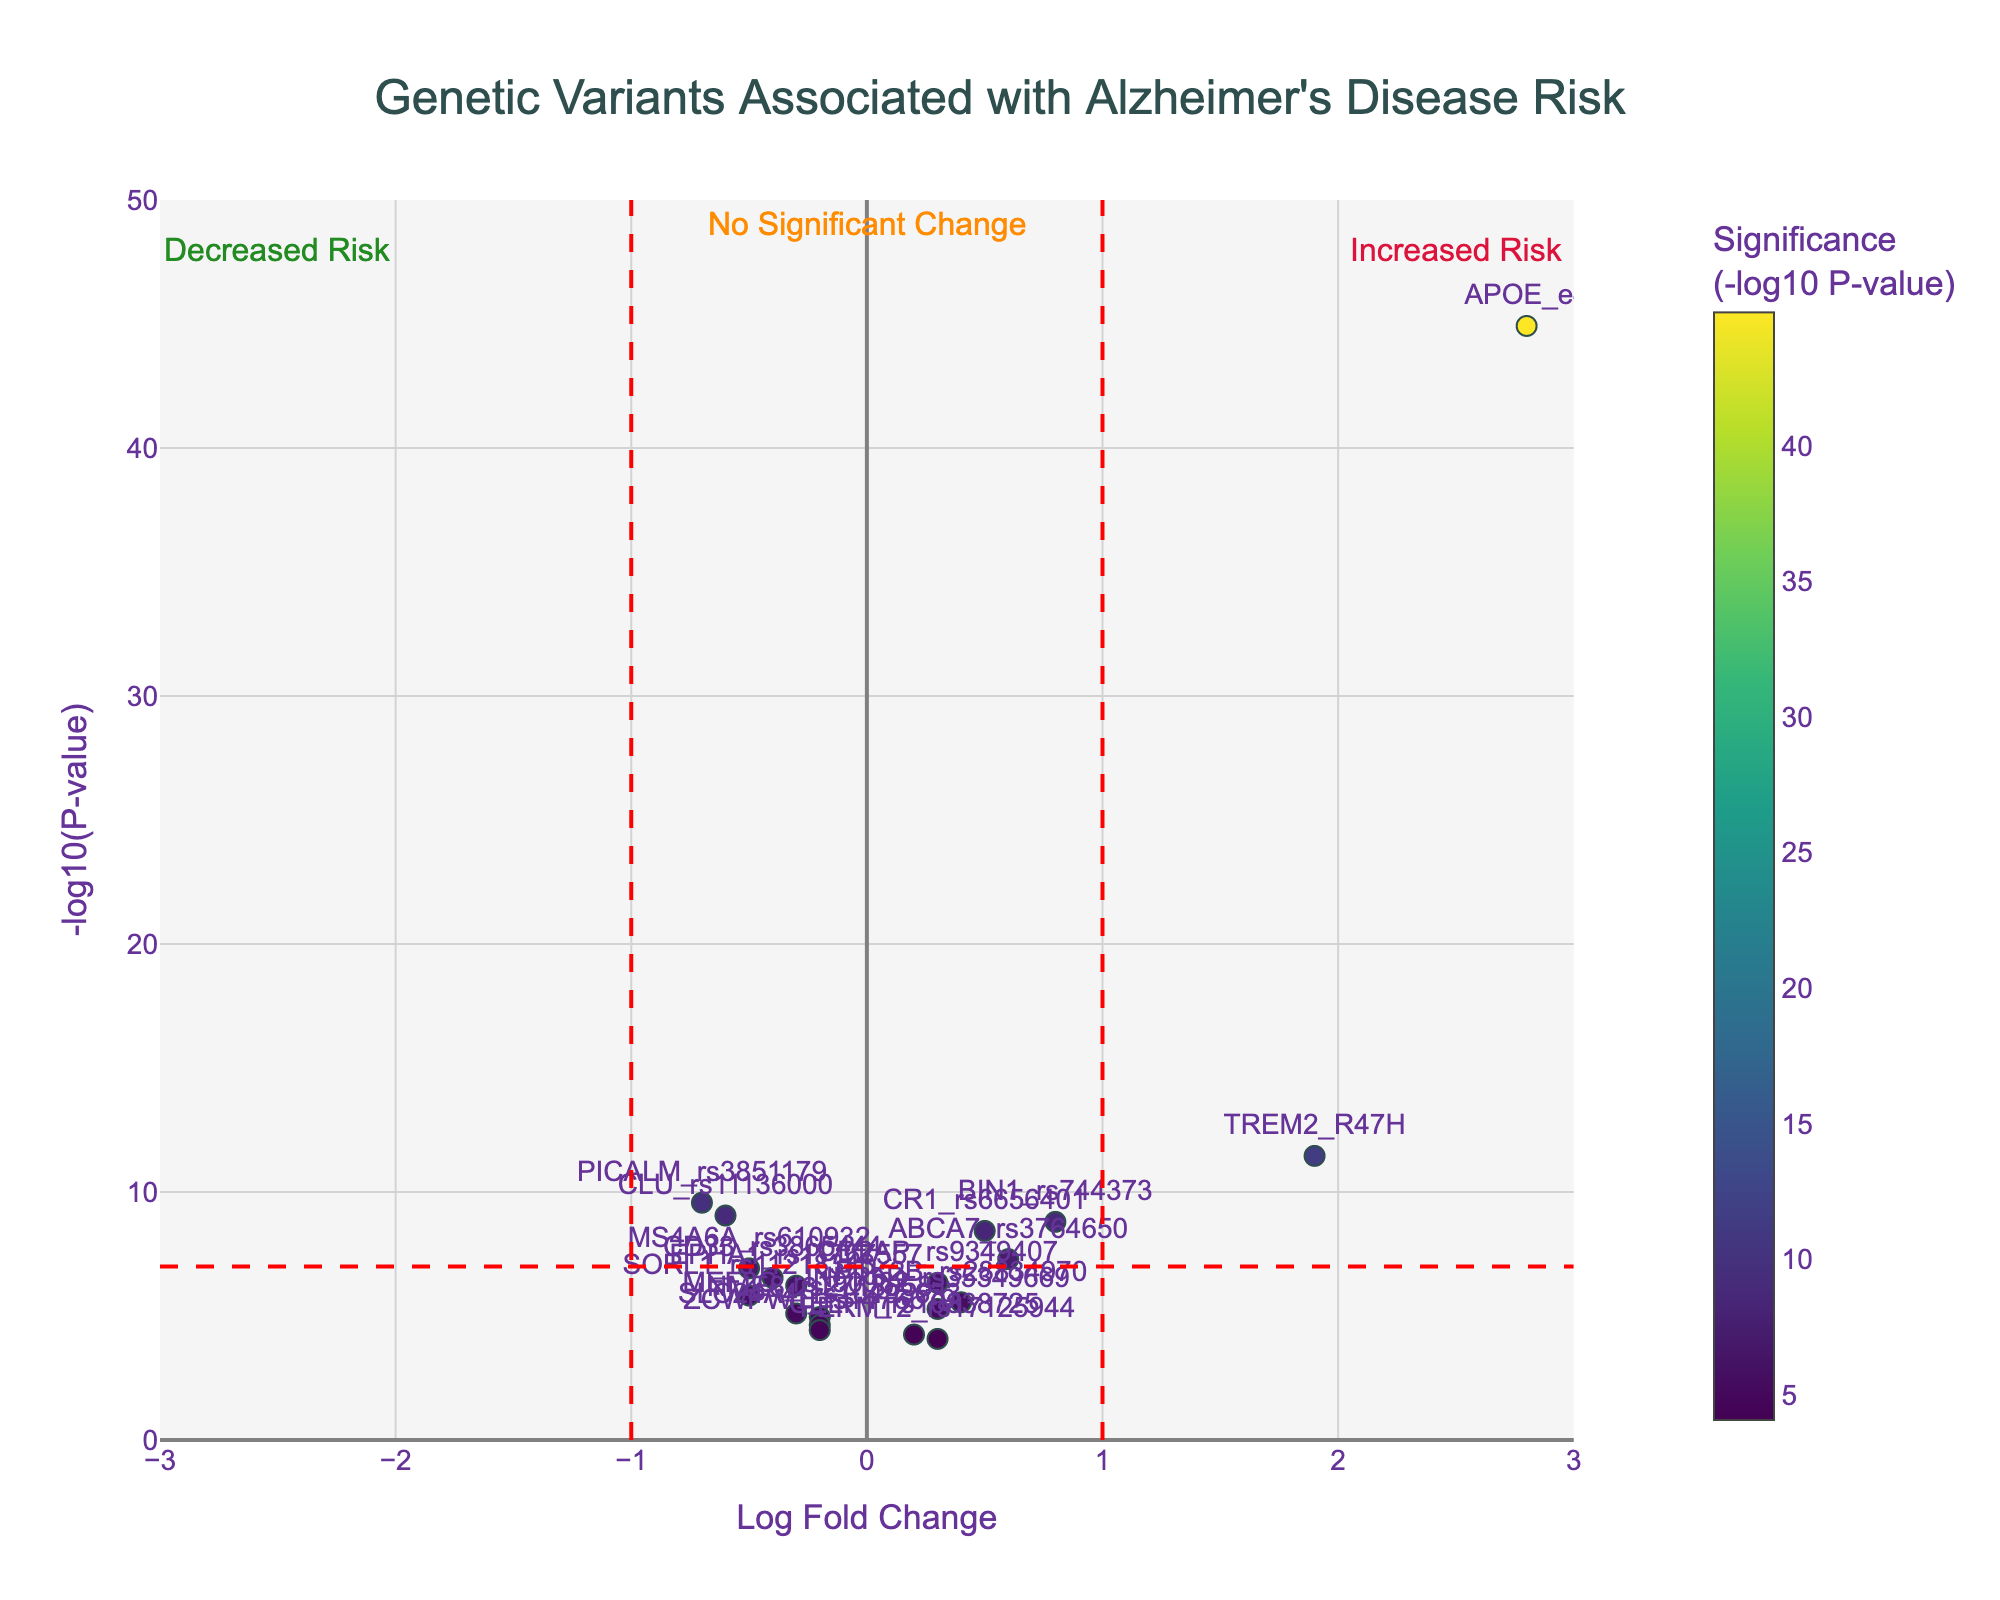What is the title of this plot? The title is displayed at the top center of the plot. Reading the title gives clear information about the context of the figure.
Answer: Genetic Variants Associated with Alzheimer's Disease Risk What do the colors of the data points represent? The color of the data points is linked to the significance (-log10 P-value) of each SNP and this is explained by the color bar on the right-hand side of the plot.
Answer: Significance (-log10 P-value) How many genetic variants (SNPs) are plotted in this figure? Each data point represents an SNP, and by counting all unique SNP labels in the figure, we find the number of plotted SNPs.
Answer: 19 Which SNP has the highest significance for Alzheimer’s disease risk? The SNP with the highest -log10(P-value) represents the most significant genetic variant. By looking at the y-axis and finding the topmost point, we identify the SNP.
Answer: APOE_e4 Which SNPs are considered to indicate an increased risk of Alzheimer’s disease? SNPs with a positive Log Fold Change value indicate increased risk. By looking at the positive side of the x-axis, we can identify these SNPs.
Answer: APOE_e4, TREM2_R47H, BIN1_rs744373, CR1_rs6656401, ABCA7_rs3764650, CD2AP_rs9349407, PTK2B_rs28834970, INPP5D_rs35349669, FERMT2_rs17125944 What does a Log Fold Change of negative value indicate in terms of Alzheimer's disease risk? A negative Log Fold Change value indicates a decreased risk of Alzheimer's disease, as per the annotations in the plot.
Answer: Decreased risk Which SNP has the smallest Log Fold Change but is still considered significant? By identifying SNPs with significant P-values (-log10(P-value) > 7), we locate the smallest Log Fold Change which is closest to zero.
Answer: CD2AP_rs9349407 How many SNPs exhibit a significant association (with -log10(P-value) > 7) and a decreased risk (negative Log Fold Change)? By looking at the threshold line for -log10(P-value) and counts of points on the left side of the x-axis, we determine the number of such SNPs.
Answer: 4 (PICALM_rs3851179, CLU_rs11136000, MS4A6A_rs610932, SORL1_rs11218343) Which has greater significance, TREM2_R47H or PICALM_rs3851179? Compare the y-values of TREM2_R47H and PICALM_rs3851179 to determine which one is higher.
Answer: TREM2_R47H What does the horizontal red dashed line represent in this plot? The annotation near the line specifies the threshold for significance, as it marks the y-axis value of 7.
Answer: Significance threshold (-log10(P-value) = 7) 